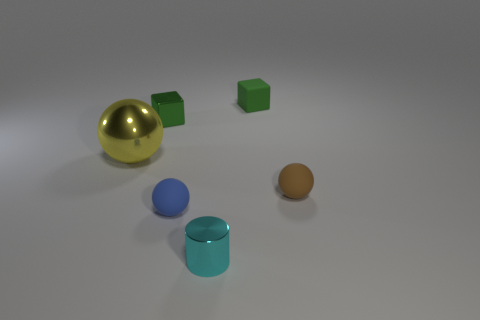Subtract all yellow spheres. How many spheres are left? 2 Subtract all brown balls. How many balls are left? 2 Subtract all brown cubes. Subtract all brown cylinders. How many cubes are left? 2 Subtract all large objects. Subtract all yellow objects. How many objects are left? 4 Add 2 rubber cubes. How many rubber cubes are left? 3 Add 2 blue spheres. How many blue spheres exist? 3 Add 3 tiny cyan objects. How many objects exist? 9 Subtract 1 cyan cylinders. How many objects are left? 5 Subtract all cylinders. How many objects are left? 5 Subtract 1 cylinders. How many cylinders are left? 0 